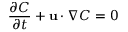<formula> <loc_0><loc_0><loc_500><loc_500>\frac { \partial C } { \partial t } + u \cdot \nabla C = 0</formula> 